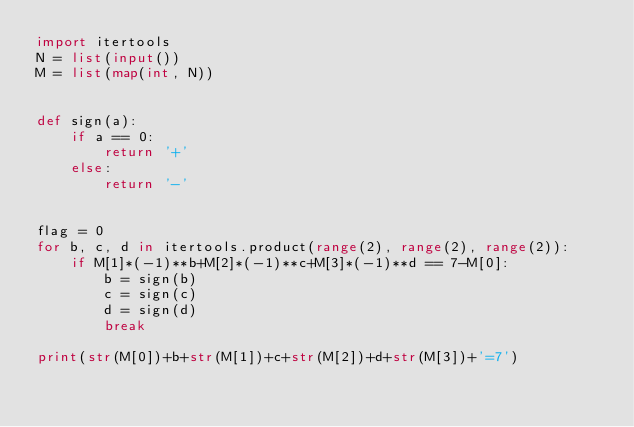Convert code to text. <code><loc_0><loc_0><loc_500><loc_500><_Python_>import itertools
N = list(input())
M = list(map(int, N))


def sign(a):
    if a == 0:
        return '+'
    else:
        return '-'


flag = 0
for b, c, d in itertools.product(range(2), range(2), range(2)):
    if M[1]*(-1)**b+M[2]*(-1)**c+M[3]*(-1)**d == 7-M[0]:
        b = sign(b)
        c = sign(c)
        d = sign(d)
        break

print(str(M[0])+b+str(M[1])+c+str(M[2])+d+str(M[3])+'=7')
</code> 